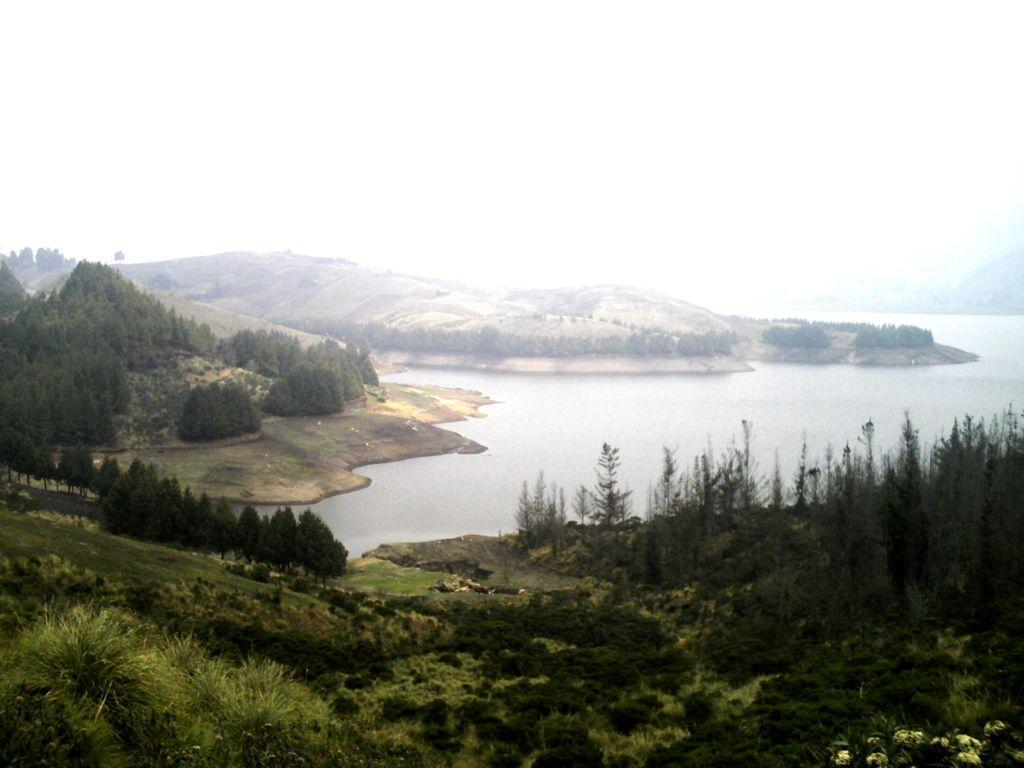How would you summarize this image in a sentence or two? In this image we can see some trees, plants, grass, water and mountains, in the background, we can see the sky. 